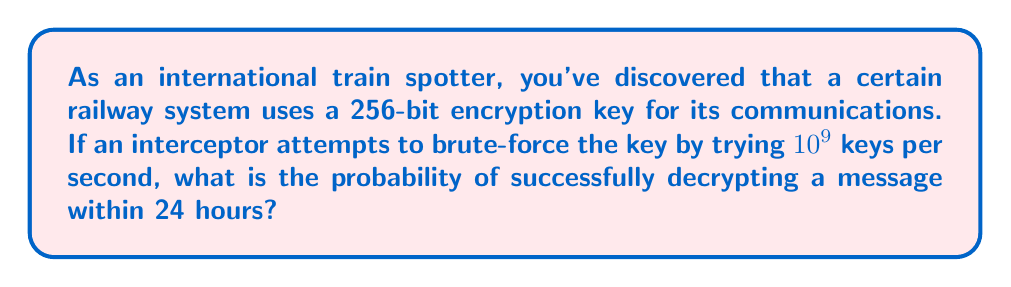Can you answer this question? Let's approach this step-by-step:

1) First, we need to calculate the total number of possible 256-bit keys:
   $$2^{256} = 1.1579 \times 10^{77}$$ keys

2) Now, let's calculate how many keys can be attempted in 24 hours:
   $$24 \text{ hours} \times 3600 \text{ seconds/hour} \times 10^9 \text{ keys/second} = 8.64 \times 10^{13}$$ keys

3) The probability of success is the number of keys that can be attempted divided by the total number of possible keys:

   $$P(\text{success}) = \frac{\text{Keys attempted}}{\text{Total possible keys}} = \frac{8.64 \times 10^{13}}{1.1579 \times 10^{77}}$$

4) Simplifying:
   $$P(\text{success}) = 7.4616 \times 10^{-64}$$

This extremely small probability indicates that it's virtually impossible to brute-force a 256-bit encryption key within 24 hours, even at a rate of $10^9$ attempts per second.
Answer: $7.4616 \times 10^{-64}$ 